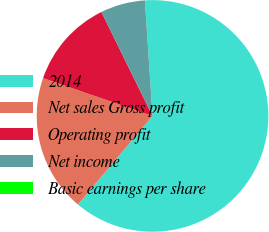Convert chart. <chart><loc_0><loc_0><loc_500><loc_500><pie_chart><fcel>2014<fcel>Net sales Gross profit<fcel>Operating profit<fcel>Net income<fcel>Basic earnings per share<nl><fcel>62.18%<fcel>19.16%<fcel>12.44%<fcel>6.22%<fcel>0.0%<nl></chart> 